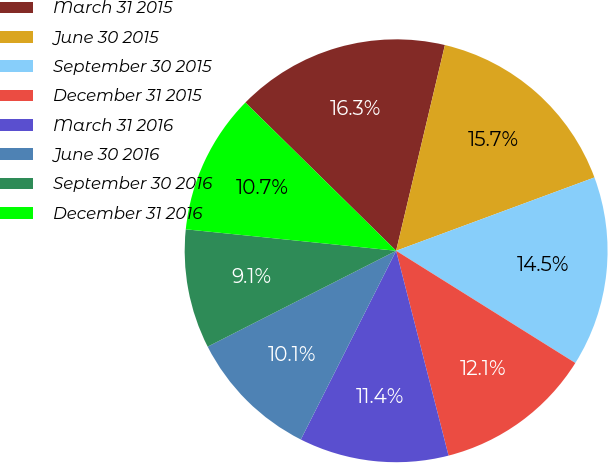Convert chart to OTSL. <chart><loc_0><loc_0><loc_500><loc_500><pie_chart><fcel>March 31 2015<fcel>June 30 2015<fcel>September 30 2015<fcel>December 31 2015<fcel>March 31 2016<fcel>June 30 2016<fcel>September 30 2016<fcel>December 31 2016<nl><fcel>16.34%<fcel>15.66%<fcel>14.54%<fcel>12.11%<fcel>11.43%<fcel>10.07%<fcel>9.11%<fcel>10.75%<nl></chart> 